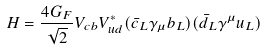<formula> <loc_0><loc_0><loc_500><loc_500>H = \frac { 4 G _ { F } } { \sqrt { 2 } } V _ { c b } V ^ { \ast } _ { u d } ( \bar { c } _ { L } \gamma _ { \mu } b _ { L } ) ( \bar { d } _ { L } \gamma ^ { \mu } u _ { L } )</formula> 